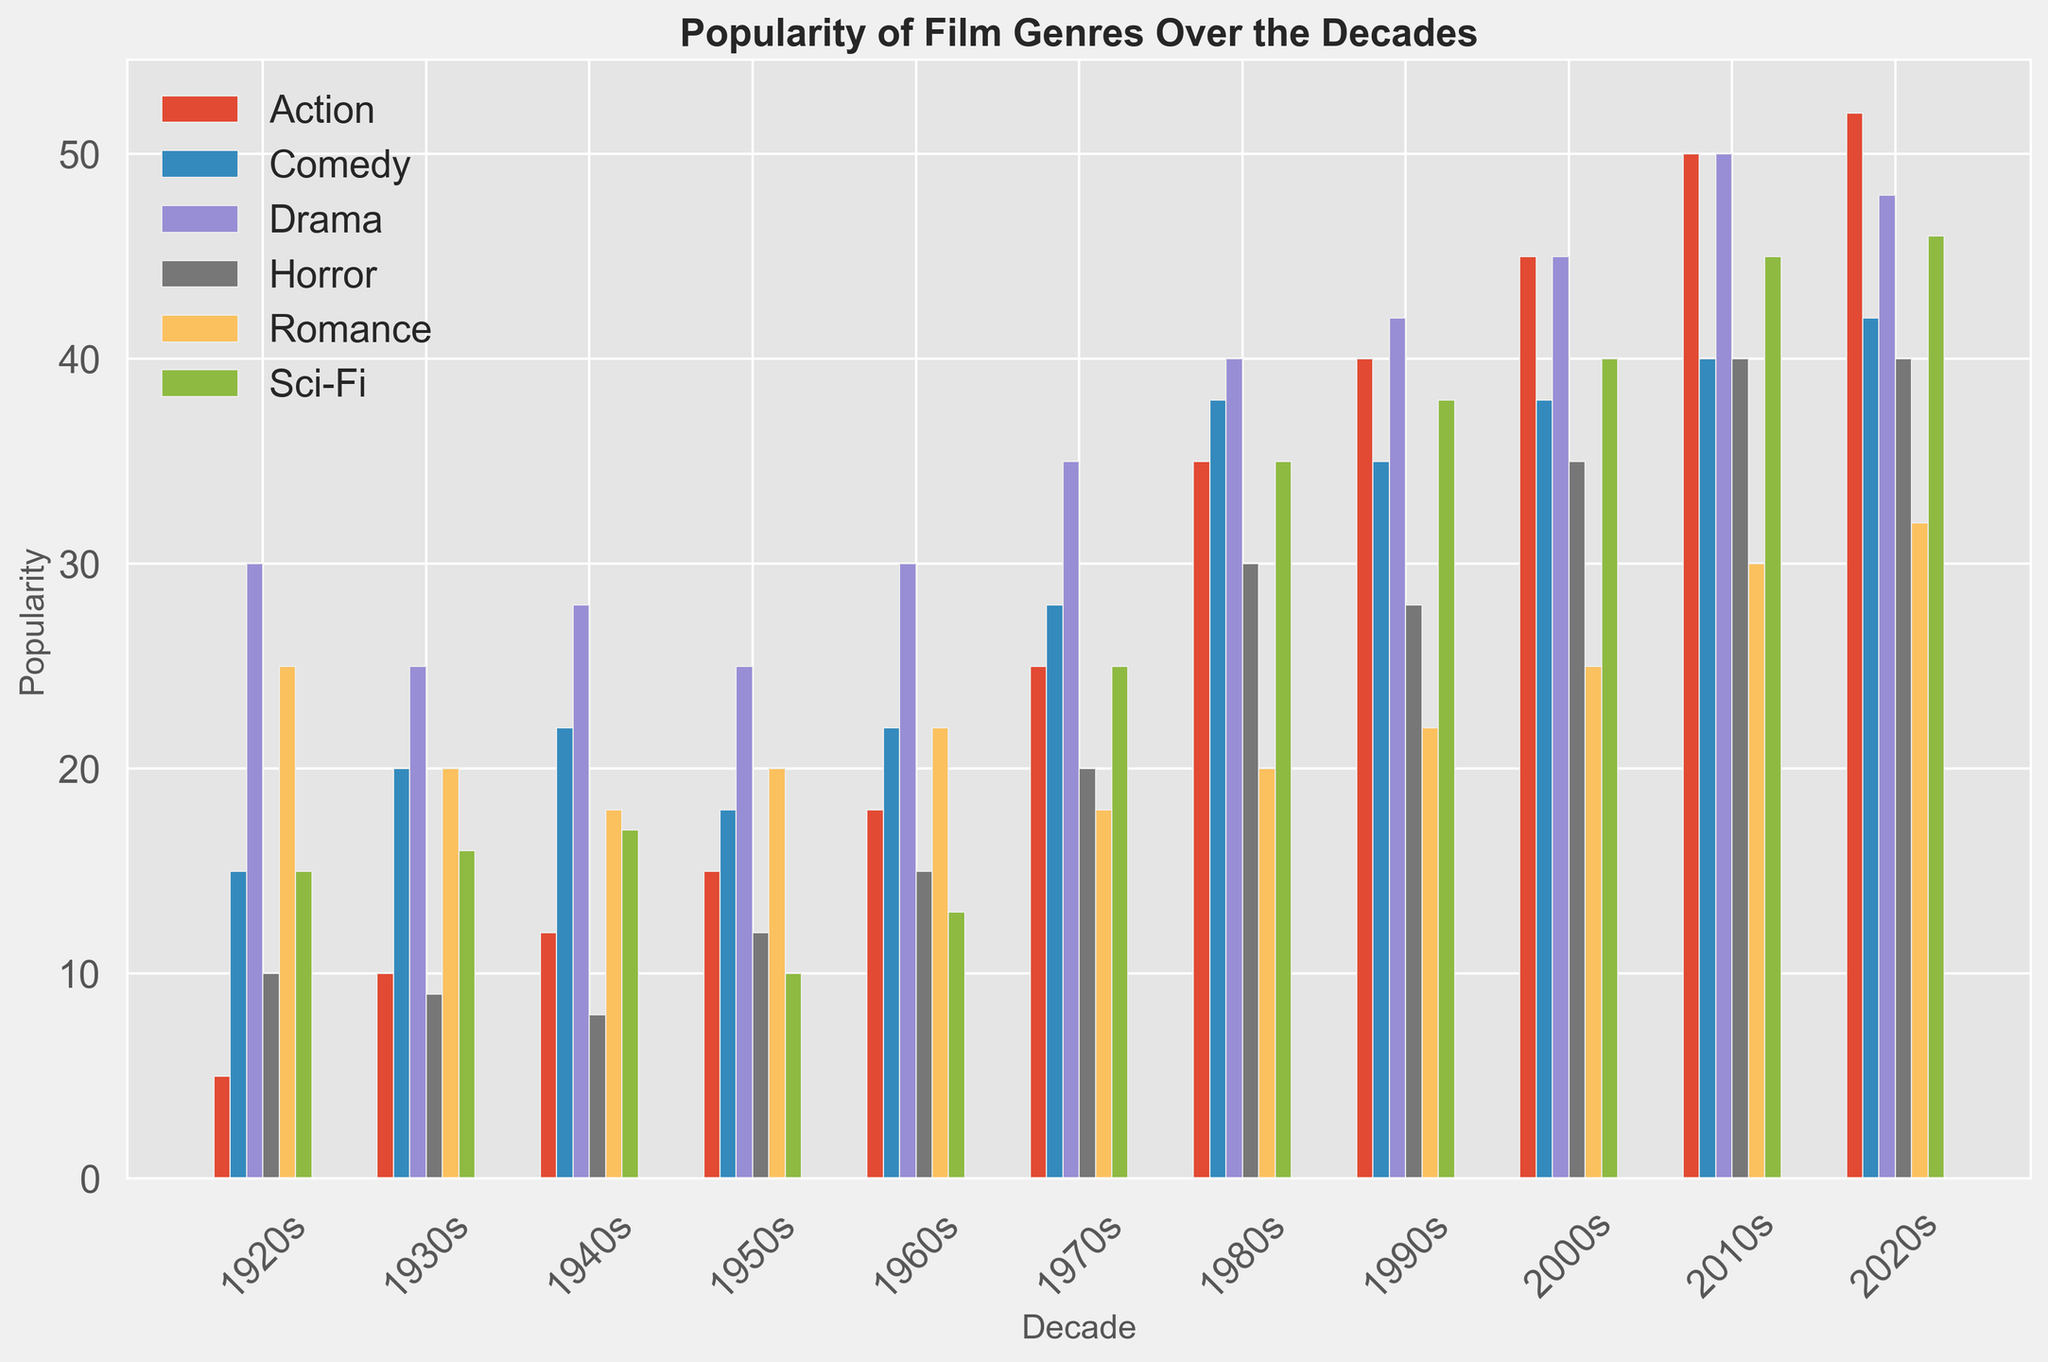What's the most popular genre in the 2010s? To identify the most popular genre in the 2010s, look at the height of the bars corresponding to that decade. The highest bar represents the most popular genre. The Sci-Fi genre is the tallest in the 2010s.
Answer: Sci-Fi Which decade saw the highest popularity in Horror films? Check the heights of the bars for the Horror genre across all decades. The tallest bar indicates the highest popularity, which occurs in the 2010s and 2020s.
Answer: 2010s and 2020s What's the difference in popularity between Action films and Romance films in the 2020s? For the 2020s, find the height of the bars for Action and Romance films and subtract the shorter from the taller. Action (52) - Romance (32) = 20.
Answer: 20 How has the popularity of Comedy films changed from the 1920s to the 2020s? Compare the heights of the Comedy bars for the 1920s and 2020s. Comedy was at 15 in the 1920s and increased to 42 in the 2020s.
Answer: Increased Which genre saw the least change in popularity from the 1920s to the 2020s? Look at the differences in bar heights for each genre between the 1920s and 2020s. Romance goes from 25 to 32, a change of 7 units, which is the smallest change among all genres.
Answer: Romance What's the total popularity of all genres combined in the 1970s? Add the heights of the bars for all genres in the 1970s: 25 (Action) + 28 (Comedy) + 35 (Drama) + 20 (Horror) + 18 (Romance) + 25 (Sci-Fi) = 151.
Answer: 151 Between the 1980s and 1990s, which genre had the largest increase in popularity? Find the difference in bar heights for each genre between the 1980s and 1990s. Sci-Fi increased the most, from 35 to 38 (increase of 3).
Answer: Sci-Fi Which genre was the least popular in the 1950s? Identify the shortest bar in the 1950s. Sci-Fi has the shortest bar at a height of 10.
Answer: Sci-Fi Compare the relative popularity of Drama and Sci-Fi across all decades. Which genre is more consistently popular? Evaluate the heights of the bars for Drama and Sci-Fi across all decades. Drama consistently has higher bar heights compared to Sci-Fi.
Answer: Drama What's the median popularity of Sci-Fi films across all decades? List the Sci-Fi values (15, 16, 17, 10, 13, 25, 35, 38, 40, 45, 46) and order them (10, 13, 15, 16, 17, 25, 35, 38, 40, 45, 46). The median is 25.
Answer: 25 